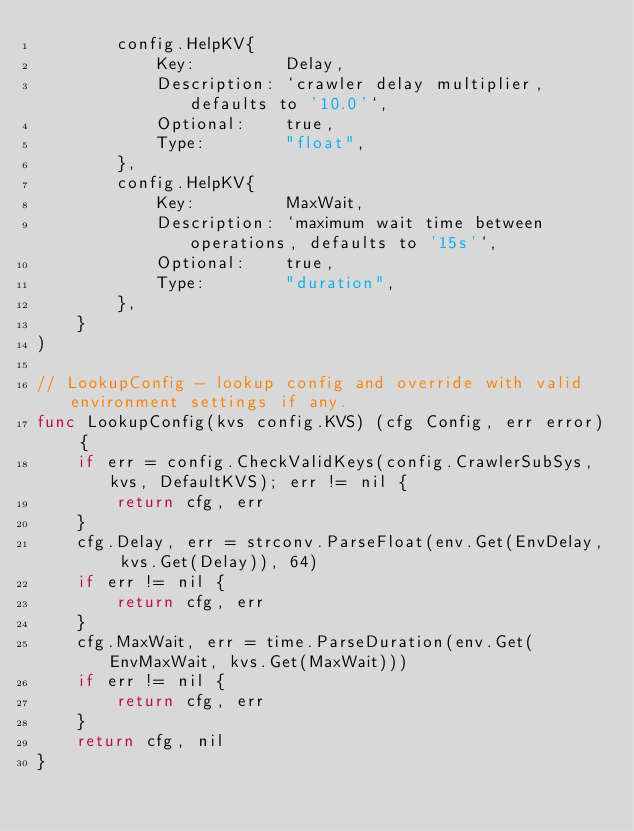Convert code to text. <code><loc_0><loc_0><loc_500><loc_500><_Go_>		config.HelpKV{
			Key:         Delay,
			Description: `crawler delay multiplier, defaults to '10.0'`,
			Optional:    true,
			Type:        "float",
		},
		config.HelpKV{
			Key:         MaxWait,
			Description: `maximum wait time between operations, defaults to '15s'`,
			Optional:    true,
			Type:        "duration",
		},
	}
)

// LookupConfig - lookup config and override with valid environment settings if any.
func LookupConfig(kvs config.KVS) (cfg Config, err error) {
	if err = config.CheckValidKeys(config.CrawlerSubSys, kvs, DefaultKVS); err != nil {
		return cfg, err
	}
	cfg.Delay, err = strconv.ParseFloat(env.Get(EnvDelay, kvs.Get(Delay)), 64)
	if err != nil {
		return cfg, err
	}
	cfg.MaxWait, err = time.ParseDuration(env.Get(EnvMaxWait, kvs.Get(MaxWait)))
	if err != nil {
		return cfg, err
	}
	return cfg, nil
}
</code> 